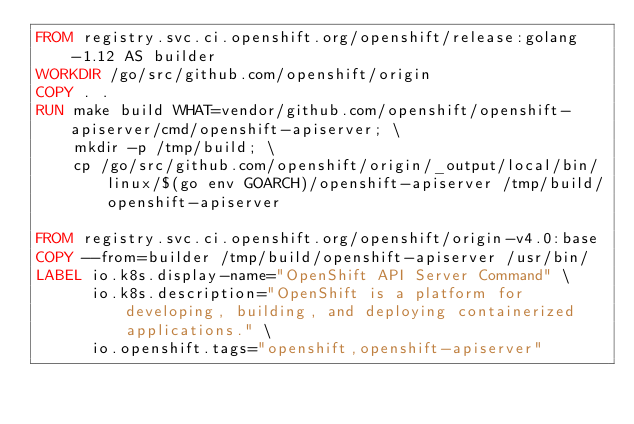<code> <loc_0><loc_0><loc_500><loc_500><_Dockerfile_>FROM registry.svc.ci.openshift.org/openshift/release:golang-1.12 AS builder
WORKDIR /go/src/github.com/openshift/origin
COPY . .
RUN make build WHAT=vendor/github.com/openshift/openshift-apiserver/cmd/openshift-apiserver; \
    mkdir -p /tmp/build; \
    cp /go/src/github.com/openshift/origin/_output/local/bin/linux/$(go env GOARCH)/openshift-apiserver /tmp/build/openshift-apiserver

FROM registry.svc.ci.openshift.org/openshift/origin-v4.0:base
COPY --from=builder /tmp/build/openshift-apiserver /usr/bin/
LABEL io.k8s.display-name="OpenShift API Server Command" \
      io.k8s.description="OpenShift is a platform for developing, building, and deploying containerized applications." \
      io.openshift.tags="openshift,openshift-apiserver"
</code> 